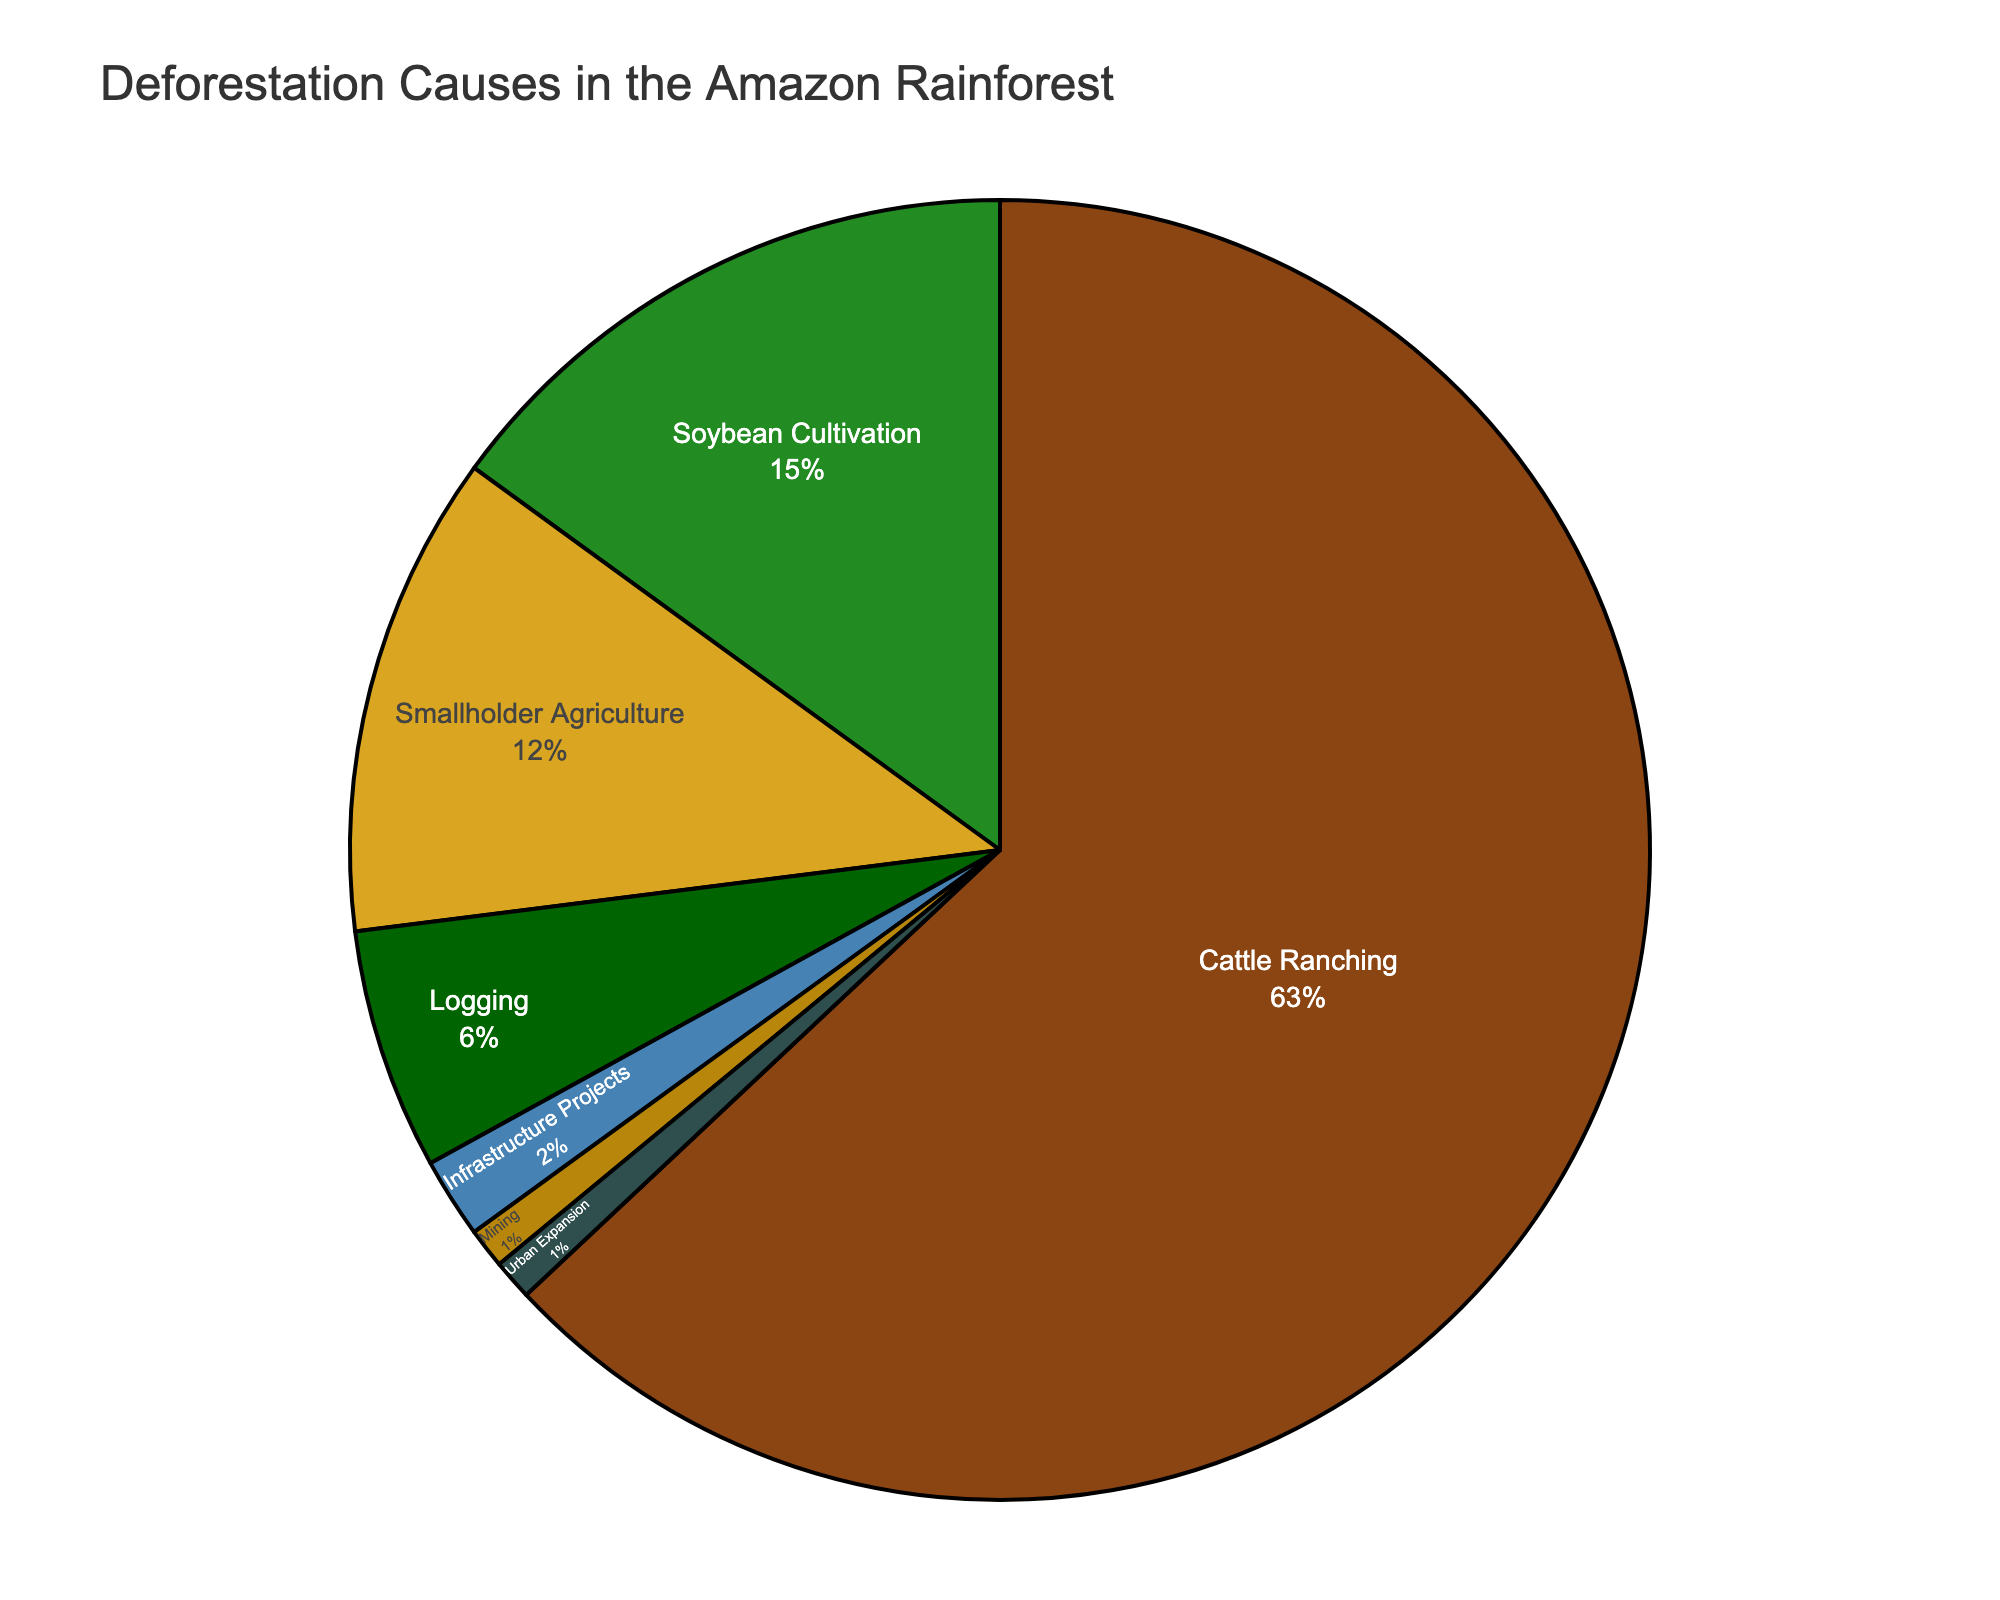What's the leading cause of deforestation in the Amazon rainforest? By looking at the largest slice of the pie chart, we can see that "Cattle Ranching" occupies the largest portion. This indicates it is the leading cause.
Answer: Cattle Ranching How much percentage do Soybean Cultivation and Smallholder Agriculture together contribute to deforestation? From the pie chart, Soybean Cultivation contributes 15% and Smallholder Agriculture contributes 12%. Adding these two percentages together gives us 15% + 12% = 27%.
Answer: 27% Which cause has the smallest contribution to deforestation, and what is its percentage? By examining the smallest slices of the pie chart, we see that both "Mining" and "Urban Expansion" have the smallest contributions, each occupying 1%.
Answer: Mining and Urban Expansion, 1% What is the percentage difference between Cattle Ranching and Logging? The percentage for Cattle Ranching is 63%, and for Logging, it is 6%. The difference between these two values is 63% - 6% = 57%.
Answer: 57% Which color represents Infrastructure Projects on the pie chart? By identifying the color used for the slice labeled "Infrastructure Projects," we can determine the representative color. In this case, it is likely the unique color used in the chart.
Answer: Light blue If we combine the percentages of Logging, Infrastructure Projects, and Mining, how much do they account for in total? The pie chart shows Logging at 6%, Infrastructure Projects at 2%, and Mining at 1%. Adding them together gives us 6% + 2% + 1% = 9%.
Answer: 9% Is Urban Expansion responsible for a greater percentage of deforestation than Mining? By comparing the slices labeled "Urban Expansion" and "Mining," we see that both have the same percentage contribution of 1%. Therefore, Urban Expansion does not have a greater percentage than Mining.
Answer: No How do Smallholder Agriculture and Logging together compare to Cattle Ranching in terms of percentage contribution? Smallholder Agriculture contributes 12% and Logging contributes 6%, for a total of 12% + 6% = 18%. Comparing this sum to Cattle Ranching's 63%, it is clear that even combined, they account for much less than Cattle Ranching.
Answer: Cattle Ranching is greater What percentage of deforestation causes are attributed to activities other than Cattle Ranching? The total percentage for other causes is obtained by subtracting Cattle Ranching's percentage from 100%. That is 100% - 63% = 37%.
Answer: 37% What is the sum of percentages for Urban Expansion and Mining? According to the pie chart, Urban Expansion and Mining each have a percentage of 1%. Adding these gives us 1% + 1% = 2%.
Answer: 2% 